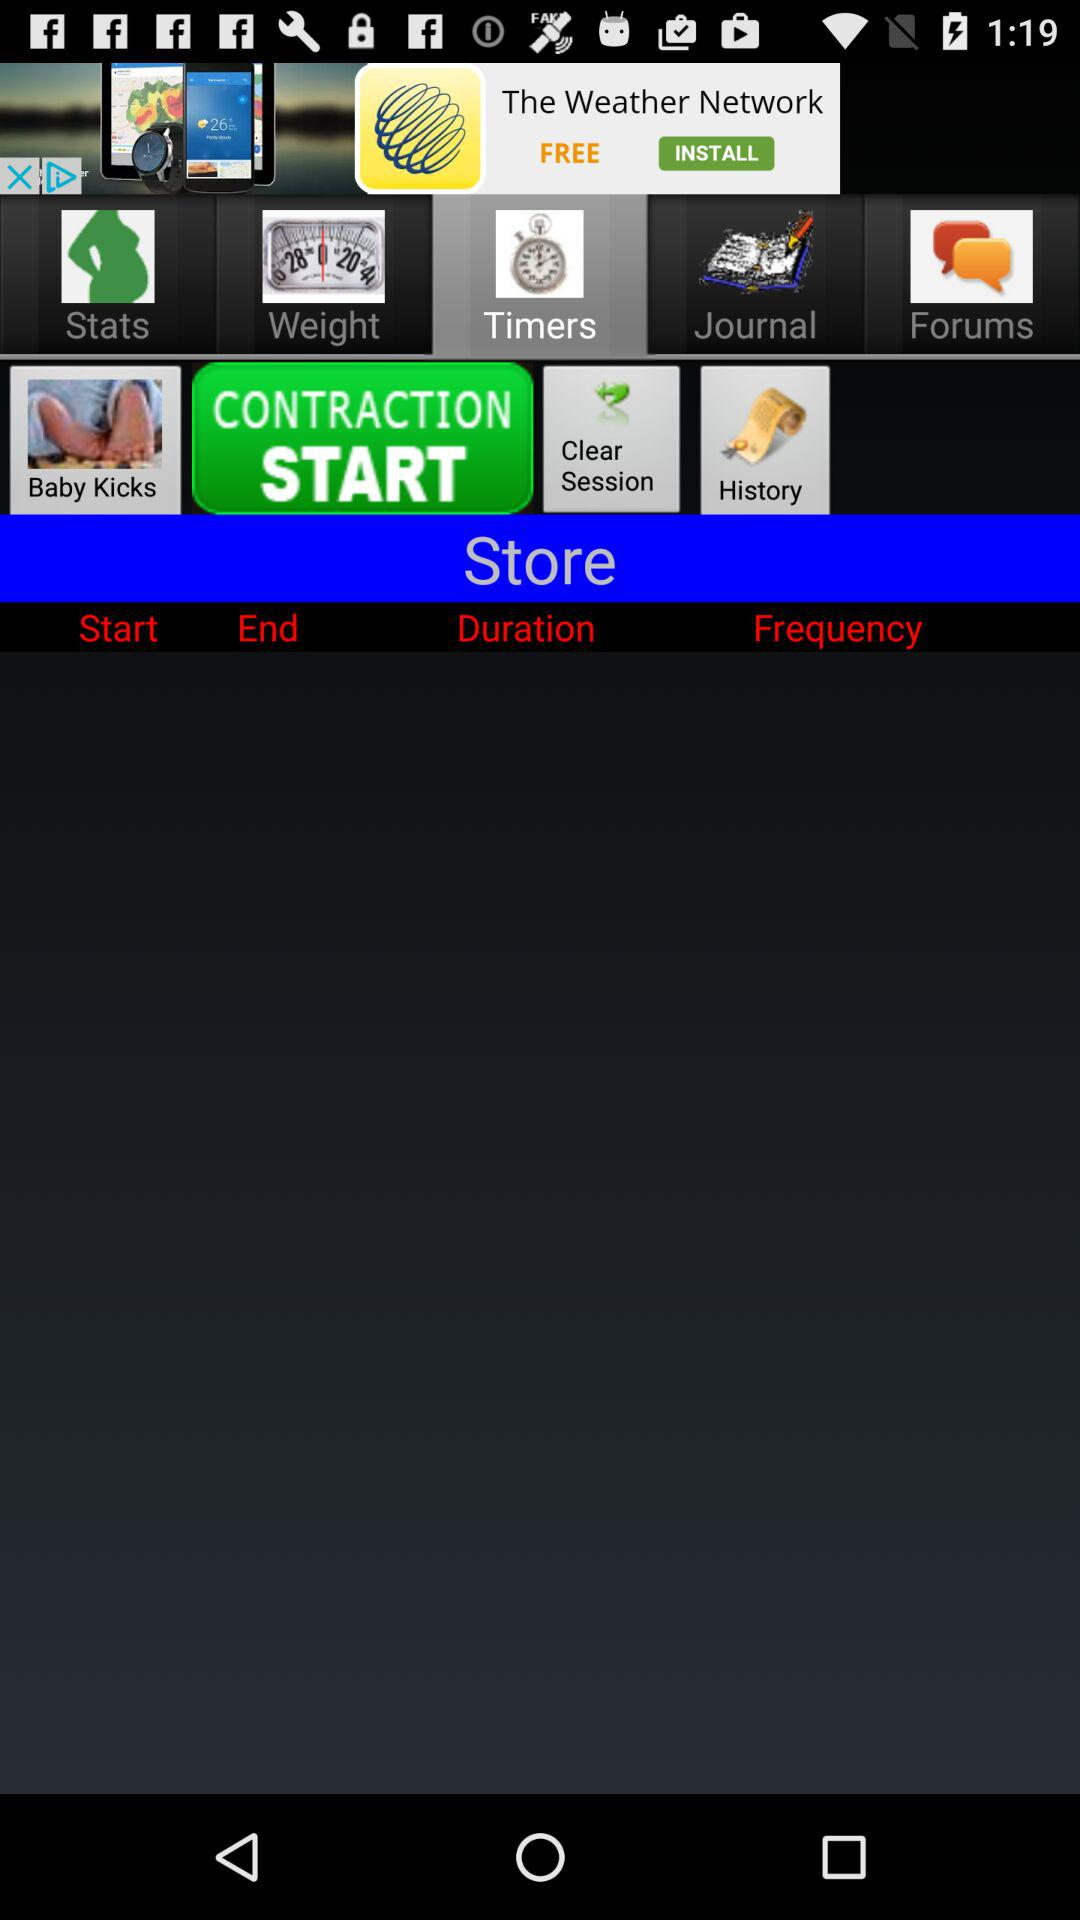What is the duration?
When the provided information is insufficient, respond with <no answer>. <no answer> 